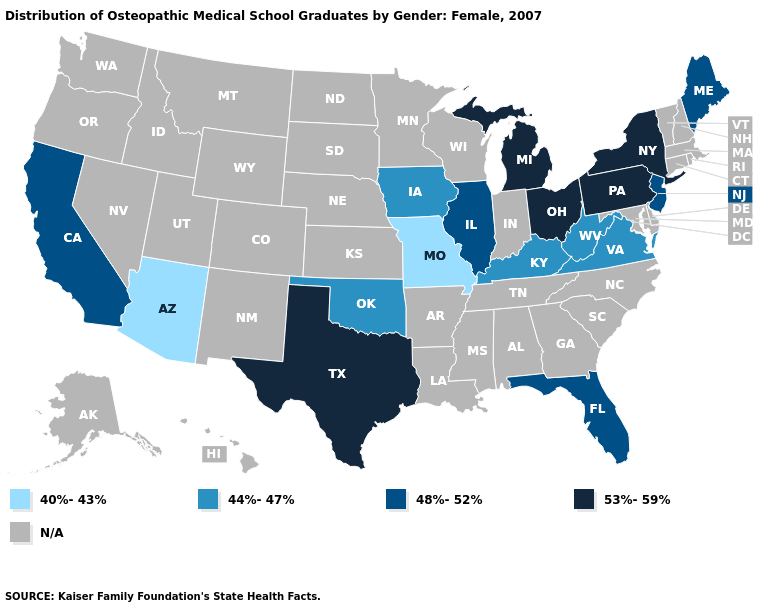Among the states that border New York , which have the highest value?
Give a very brief answer. Pennsylvania. Does Pennsylvania have the highest value in the Northeast?
Be succinct. Yes. Name the states that have a value in the range 40%-43%?
Write a very short answer. Arizona, Missouri. Does Arizona have the lowest value in the USA?
Quick response, please. Yes. How many symbols are there in the legend?
Answer briefly. 5. Name the states that have a value in the range 53%-59%?
Give a very brief answer. Michigan, New York, Ohio, Pennsylvania, Texas. What is the lowest value in the USA?
Give a very brief answer. 40%-43%. What is the value of Vermont?
Short answer required. N/A. What is the highest value in states that border Utah?
Be succinct. 40%-43%. Is the legend a continuous bar?
Give a very brief answer. No. What is the highest value in the MidWest ?
Write a very short answer. 53%-59%. What is the highest value in the USA?
Answer briefly. 53%-59%. How many symbols are there in the legend?
Be succinct. 5. 